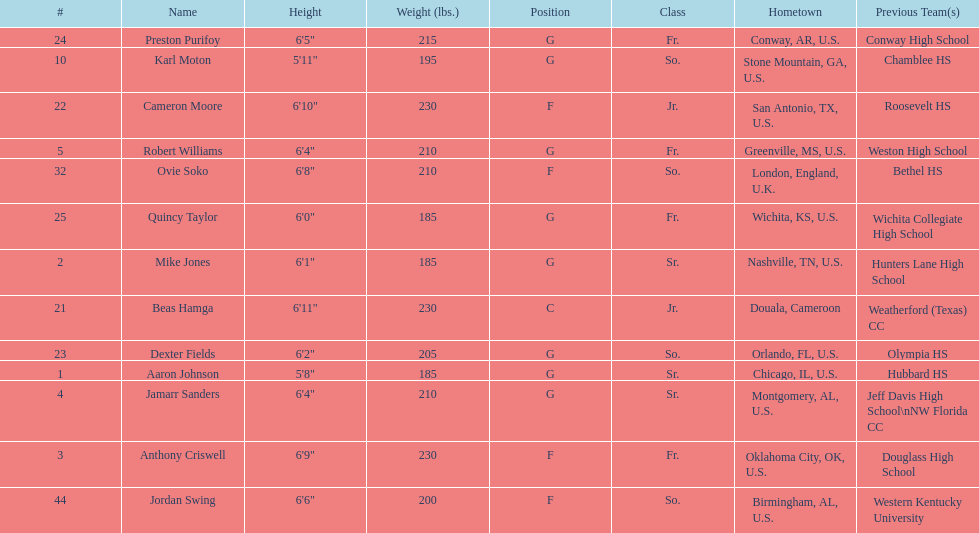Who is the tallest player on the team? Beas Hamga. 